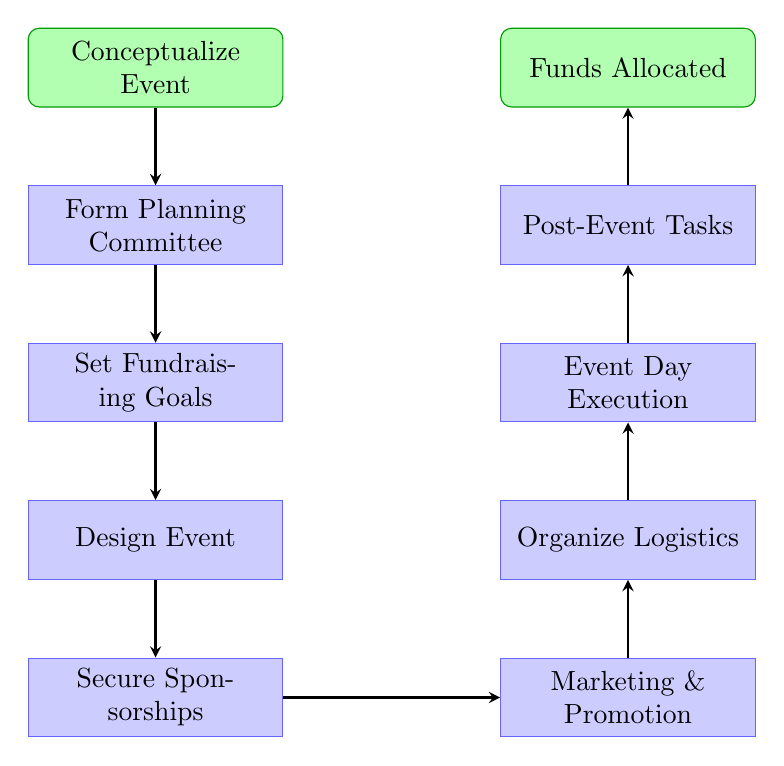What is the first step in the diagram? The first step in the diagram is labeled "Conceptualize Event," which is the starting point of the flow.
Answer: Conceptualize Event How many major steps are there from the start to the end? Counting the nodes from "Conceptualize Event" to "Funds Allocated," there are eight major steps listed in the diagram.
Answer: Eight What step comes directly after "Secure Sponsorships"? The step that comes directly after "Secure Sponsorships" is "Marketing & Promotion," which follows in the flow.
Answer: Marketing & Promotion What is the final output of the diagram? The final output of the diagram is labeled "Funds Allocated to Children's Healthcare Initiatives," which represents the end result of the process.
Answer: Funds Allocated to Children's Healthcare Initiatives Which step has two substeps related to donor engagement? The "Post-Event Tasks" step includes substeps like "Thank Sponsors & Donors," which directly relates to engaging with donors after the event.
Answer: Thank Sponsors & Donors What is the relationship between "Design Event" and "Secure Sponsorships"? "Design Event" is followed by "Secure Sponsorships," indicating that securing sponsors comes after designing the event.
Answer: Sequential How many substeps are associated with "Form Planning Committee"? There are two substeps associated with "Form Planning Committee," which are "Identify Core Team" and "Assign Roles."
Answer: Two What step requires the coordination of volunteer activities? The step focused on the coordination of volunteer activities is "Organize Logistics," which involves tasks to ensure a smooth event.
Answer: Organize Logistics What step directly follows "Event Day Execution"? The step that directly follows "Event Day Execution" is "Post-Event Tasks," indicating the actions needed after executing the event.
Answer: Post-Event Tasks 